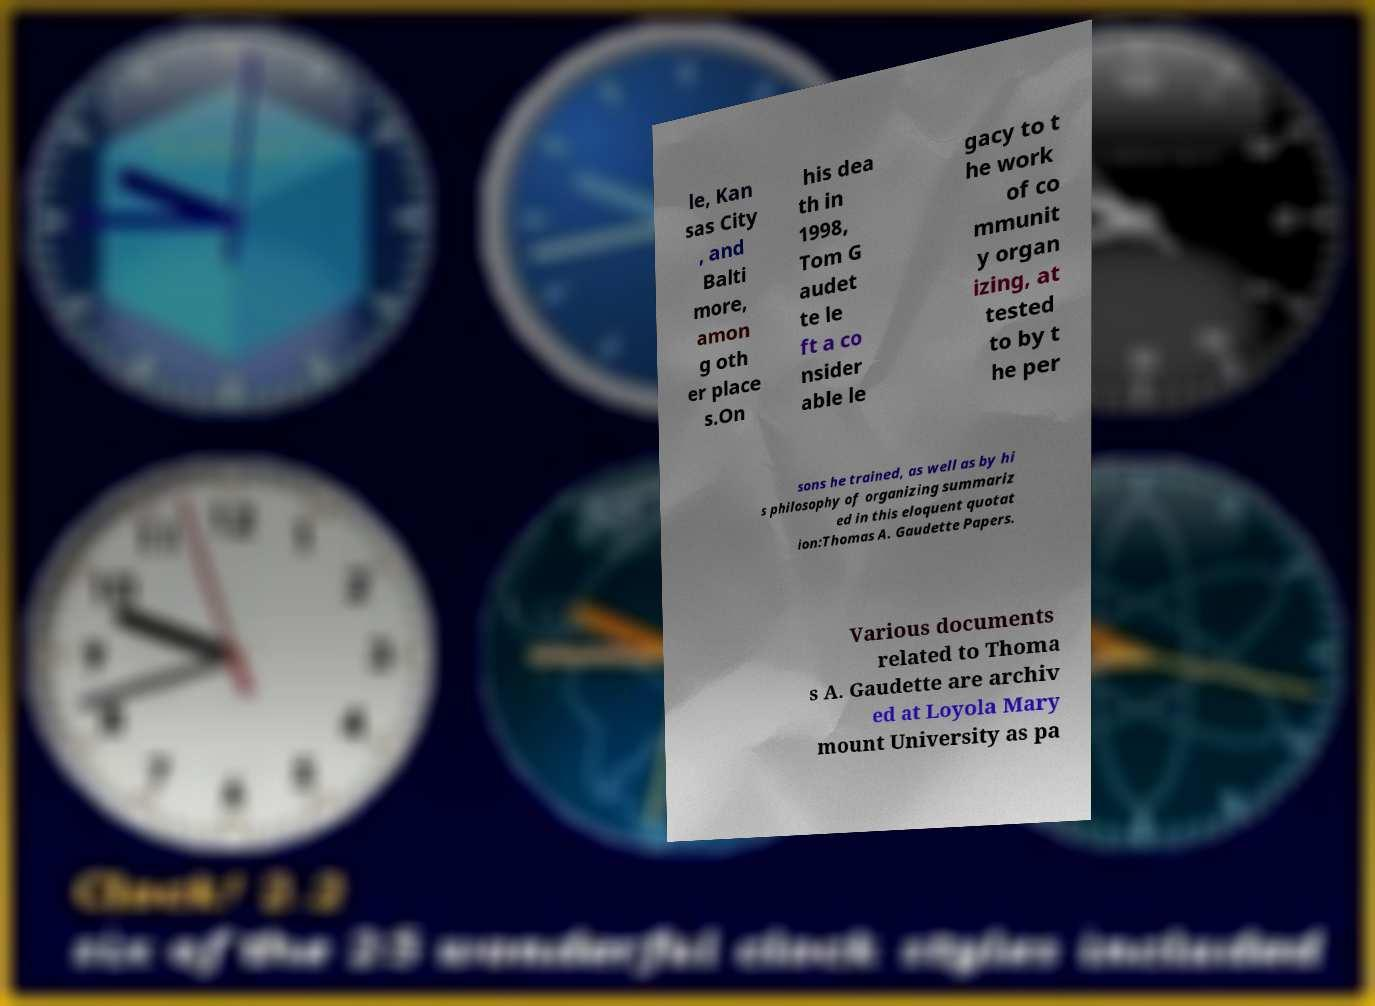Could you assist in decoding the text presented in this image and type it out clearly? le, Kan sas City , and Balti more, amon g oth er place s.On his dea th in 1998, Tom G audet te le ft a co nsider able le gacy to t he work of co mmunit y organ izing, at tested to by t he per sons he trained, as well as by hi s philosophy of organizing summariz ed in this eloquent quotat ion:Thomas A. Gaudette Papers. Various documents related to Thoma s A. Gaudette are archiv ed at Loyola Mary mount University as pa 